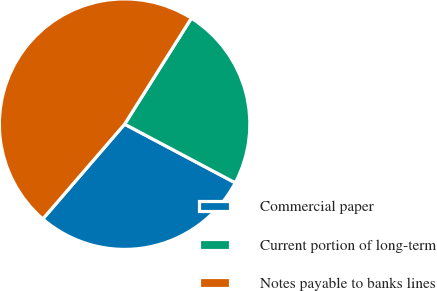Convert chart to OTSL. <chart><loc_0><loc_0><loc_500><loc_500><pie_chart><fcel>Commercial paper<fcel>Current portion of long-term<fcel>Notes payable to banks lines<nl><fcel>28.57%<fcel>23.81%<fcel>47.62%<nl></chart> 